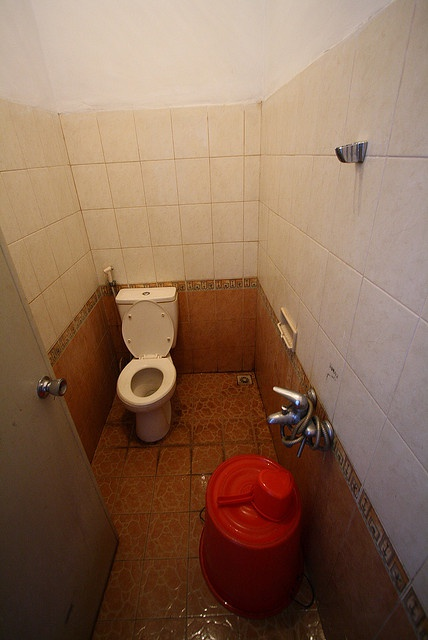Describe the objects in this image and their specific colors. I can see a toilet in darkgray, tan, maroon, and gray tones in this image. 